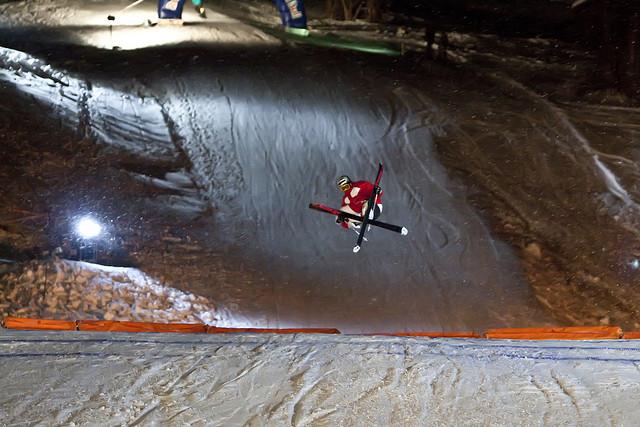What letter do the skis form?
Answer briefly. X. How many people skiing?
Concise answer only. 1. Is the skier in the air?
Concise answer only. Yes. 